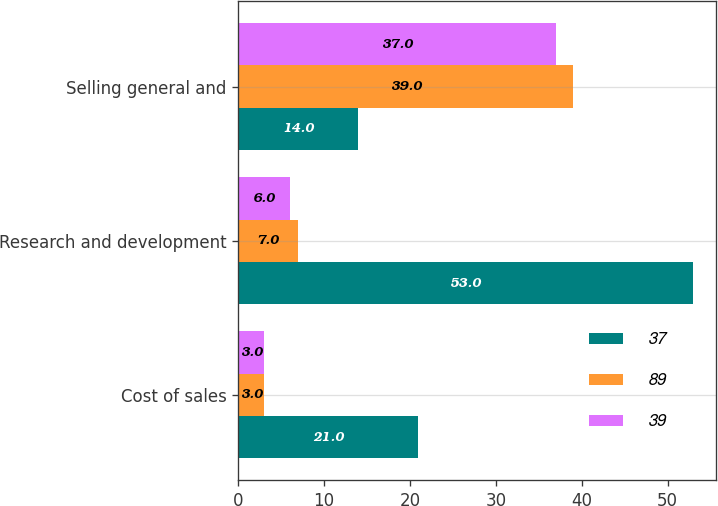Convert chart. <chart><loc_0><loc_0><loc_500><loc_500><stacked_bar_chart><ecel><fcel>Cost of sales<fcel>Research and development<fcel>Selling general and<nl><fcel>37<fcel>21<fcel>53<fcel>14<nl><fcel>89<fcel>3<fcel>7<fcel>39<nl><fcel>39<fcel>3<fcel>6<fcel>37<nl></chart> 